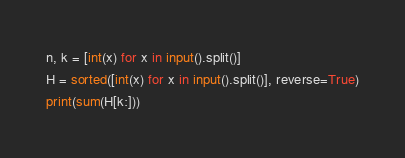Convert code to text. <code><loc_0><loc_0><loc_500><loc_500><_Python_>n, k = [int(x) for x in input().split()]
H = sorted([int(x) for x in input().split()], reverse=True)
print(sum(H[k:]))
</code> 